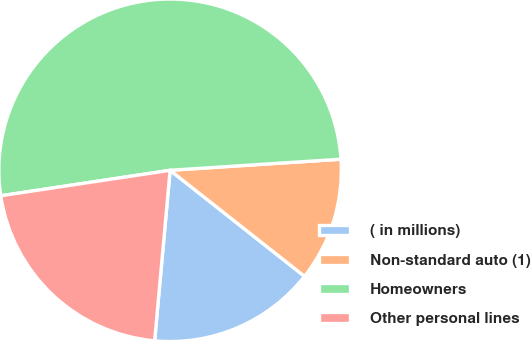<chart> <loc_0><loc_0><loc_500><loc_500><pie_chart><fcel>( in millions)<fcel>Non-standard auto (1)<fcel>Homeowners<fcel>Other personal lines<nl><fcel>15.81%<fcel>11.66%<fcel>51.34%<fcel>21.18%<nl></chart> 